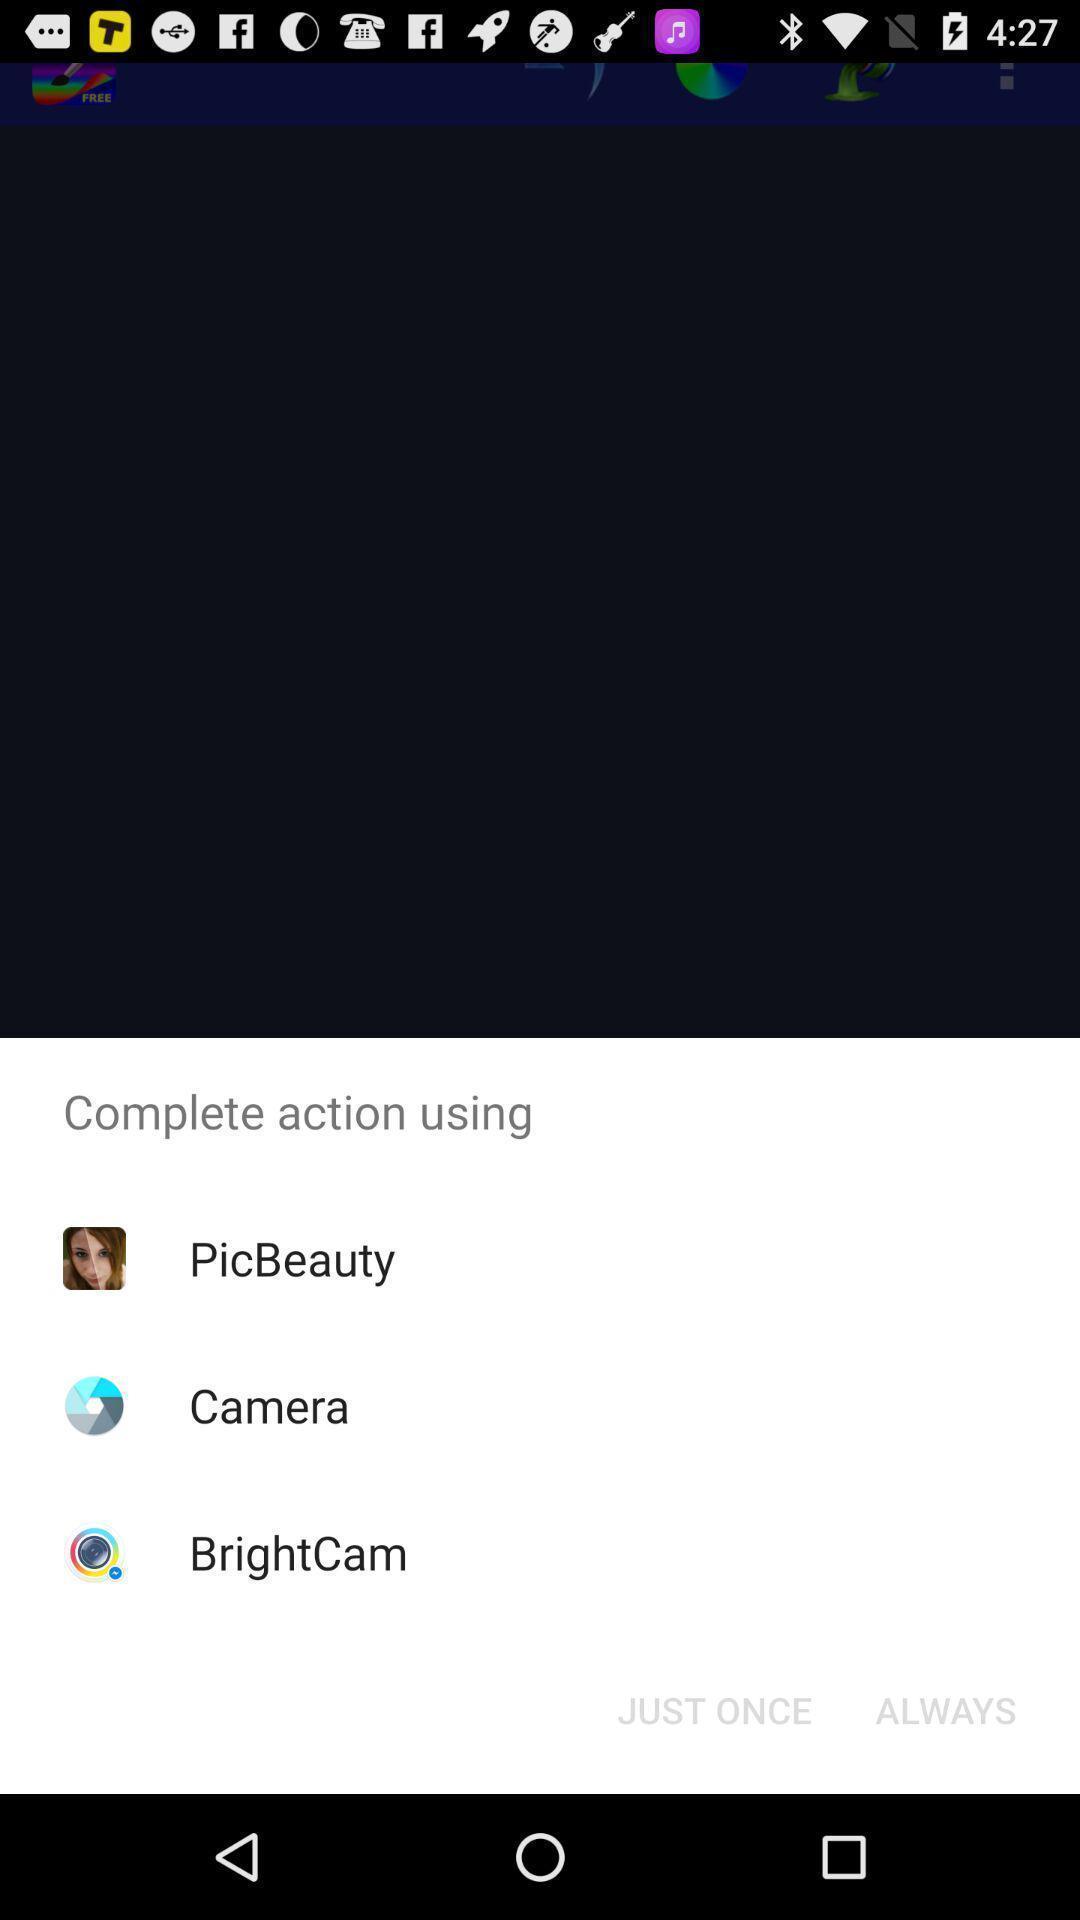Tell me what you see in this picture. Pop-up shows complete action using multiple options. 